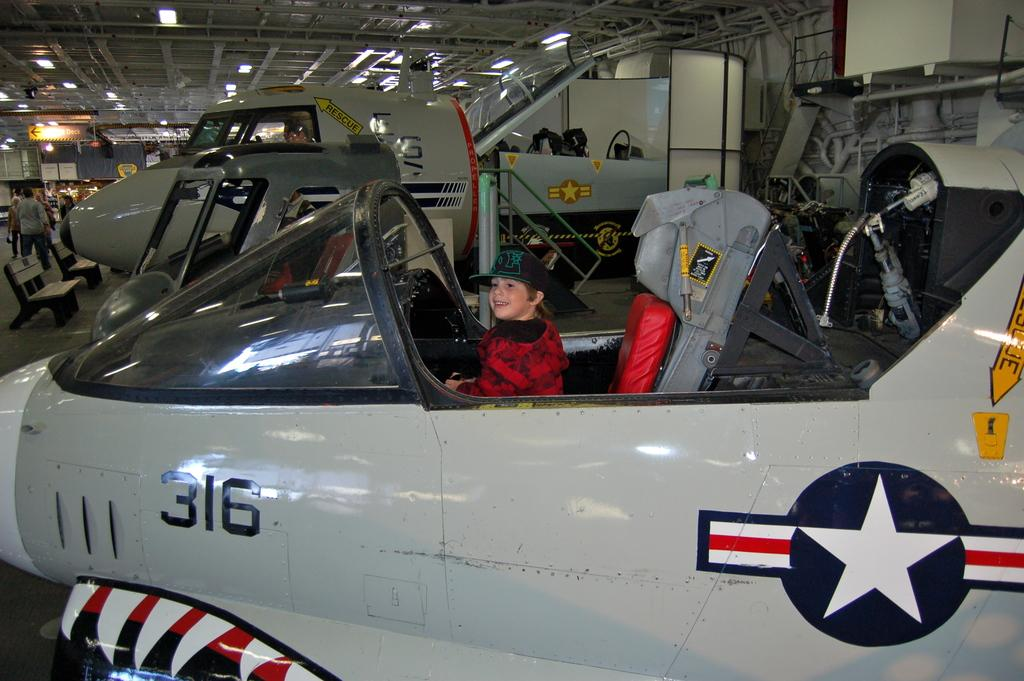<image>
Relay a brief, clear account of the picture shown. A small boy is sitting in the cockpit of a fighter jet with the number 316 on it. 